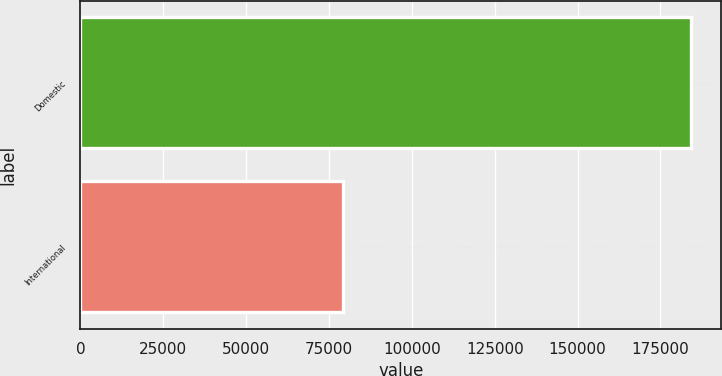Convert chart to OTSL. <chart><loc_0><loc_0><loc_500><loc_500><bar_chart><fcel>Domestic<fcel>International<nl><fcel>184086<fcel>79175<nl></chart> 